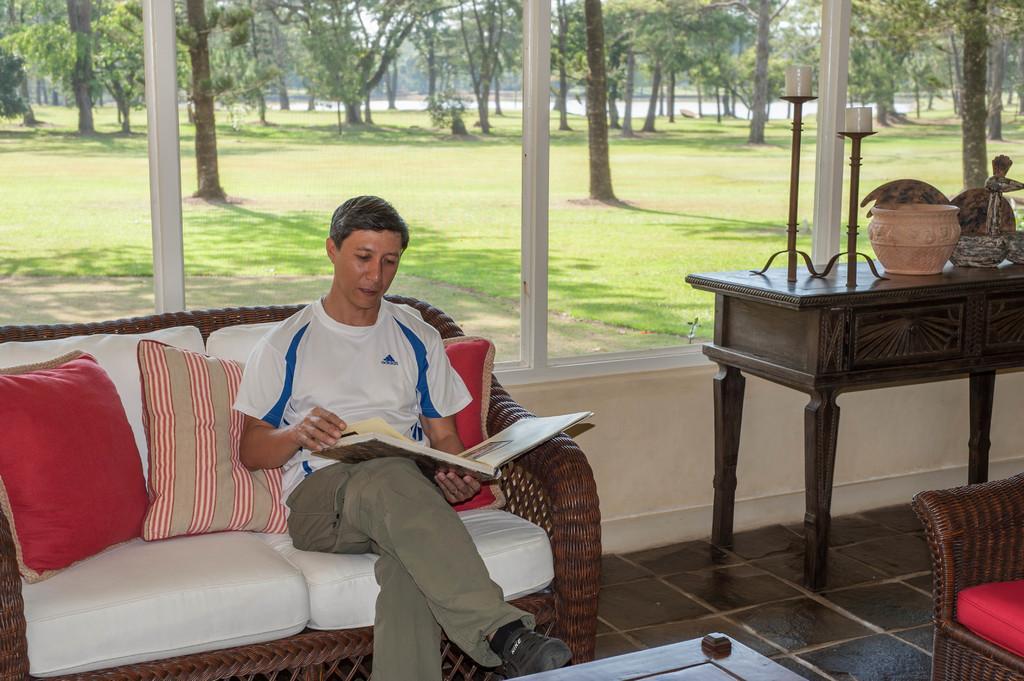Please provide a concise description of this image. In this image there is a person wearing black color dress sitting on the couch and reading something at the background of the image there are some trees and window. 